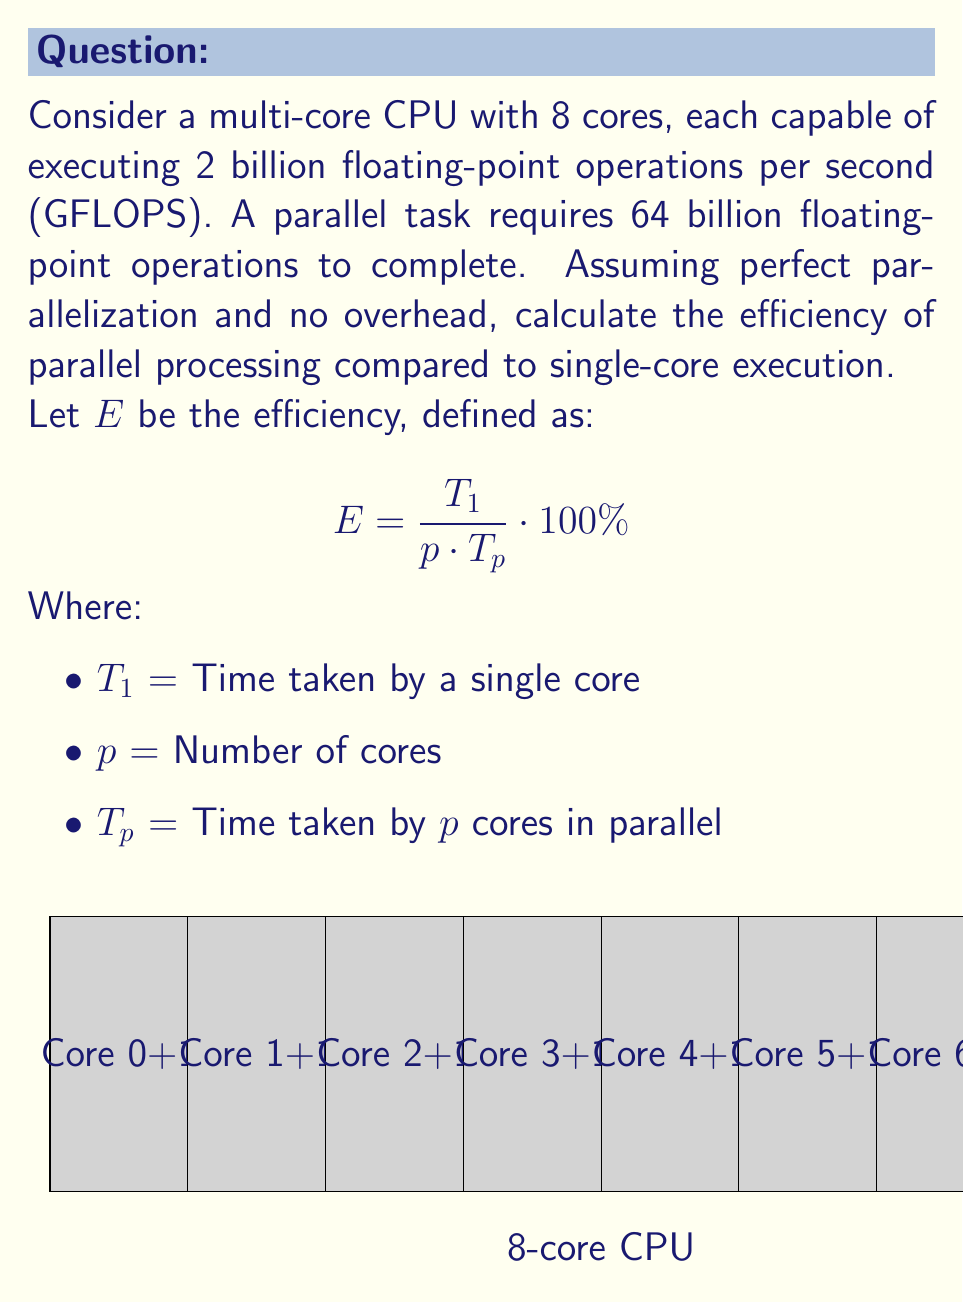Can you solve this math problem? To solve this problem, we'll follow these steps:

1) Calculate $T_1$ (time for single core):
   $T_1 = \frac{\text{Total operations}}{\text{Operations per second for one core}}$
   $T_1 = \frac{64 \times 10^9}{2 \times 10^9} = 32$ seconds

2) Calculate $T_p$ (time for 8 cores in parallel):
   $T_p = \frac{\text{Total operations}}{\text{Operations per second for all cores}}$
   $T_p = \frac{64 \times 10^9}{8 \times 2 \times 10^9} = 4$ seconds

3) Apply the efficiency formula:
   $$ E = \frac{T_1}{p \cdot T_p} \cdot 100\% $$
   $$ E = \frac{32}{8 \cdot 4} \cdot 100\% $$
   $$ E = \frac{32}{32} \cdot 100\% = 100\% $$

The efficiency is 100%, which means perfect scaling. This is expected because we assumed perfect parallelization and no overhead in the question.

In real-world scenarios, efficiency is typically less than 100% due to factors like communication overhead, load imbalance, and parts of the task that cannot be parallelized (Amdahl's Law).
Answer: 100% 